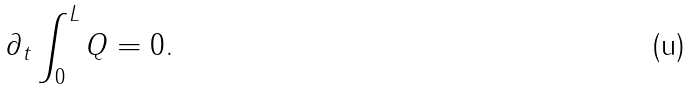<formula> <loc_0><loc_0><loc_500><loc_500>\partial _ { t } \int _ { 0 } ^ { L } Q = 0 .</formula> 